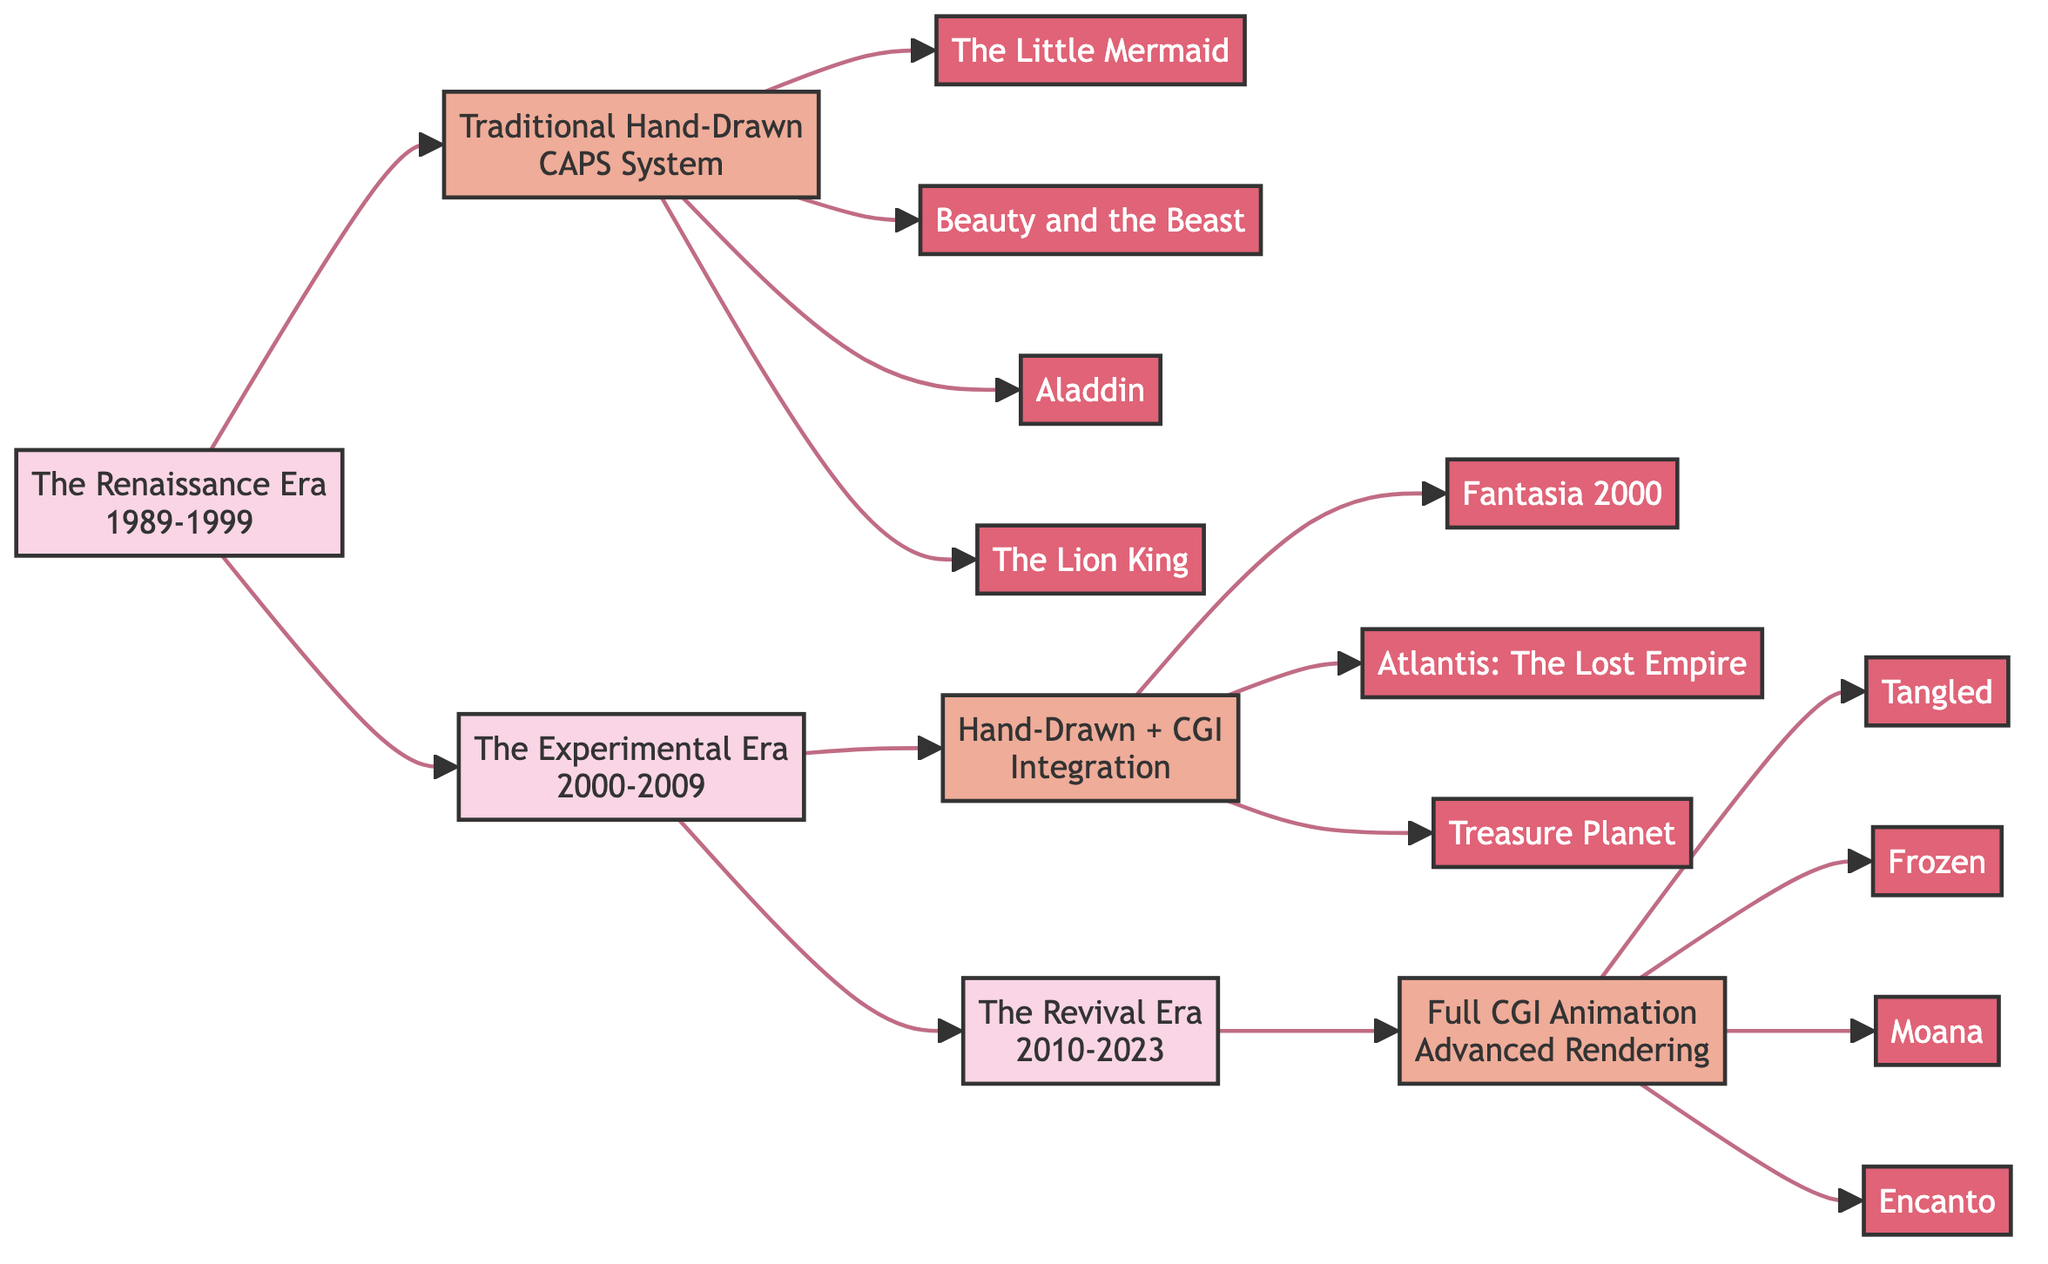What era does "The Lion King" belong to? "The Lion King" is listed under the movies in "The Renaissance Era," indicating that it was released between 1989 and 1999.
Answer: The Renaissance Era How many movies are associated with the Experimental Era? The Experimental Era has three movies detailed in the diagram: "Fantasia 2000," "Atlantis: The Lost Empire," and "Treasure Planet."
Answer: 3 What is the notable achievement of the Revival Era? The diagram states that the notable achievement of the Revival Era is "Advancements in Rendering and Realism," which relates to the technology employed in this time period.
Answer: Advancements in Rendering and Realism Which technology is associated with the movies from the Renaissance Era? The technology listed for the Renaissance Era is "Traditional Hand-Drawn" along with the mention of the "CAPS (Computer Animation Production System)," indicating the animation style used during that period.
Answer: Traditional Hand-Drawn How is the technology of the Experimental Era different from the Renaissance Era? While the Renaissance Era uses only "Traditional Hand-Drawn" animation, the Experimental Era combines "Hand-Drawn and CGI," showing a shift towards modern techniques in animation.
Answer: Hand-Drawn and CGI What signature song is associated with "Frozen"? According to the diagram, the signature song of the movie "Frozen" is "Let It Go." This information can be found next to the Revival Era.
Answer: Let It Go What kind of animation was primarily used in the Revival Era? The diagram indicates that the Revival Era utilized "Full CGI Animation" as its primary animation style, representing a significant technological advancement from earlier eras.
Answer: Full CGI Animation Identify all the movie titles from the Renaissance Era. The movies listed under the Renaissance Era include "The Little Mermaid," "Beauty and the Beast," "Aladdin," and "The Lion King." By reading the corresponding section, all titles can be directly extracted.
Answer: The Little Mermaid, Beauty and the Beast, Aladdin, The Lion King What is the direct relationship between the Renaissance Era and the Experimental Era? The diagram shows a direct flow from the Renaissance Era to the Experimental Era indicating that the evolution of movie technology progressed from one to the other, demonstrating a linear relationship in the timeline.
Answer: Direct flow What key technological transition occurs from the Experimental Era to the Revival Era? The transition from the Experimental Era to the Revival Era is marked by the transition from using a combination of "Hand-Drawn and CGI" to "Full CGI Animation," illustrating a move towards entirely computer-generated graphics in animation.
Answer: Hand-Drawn and CGI to Full CGI Animation 